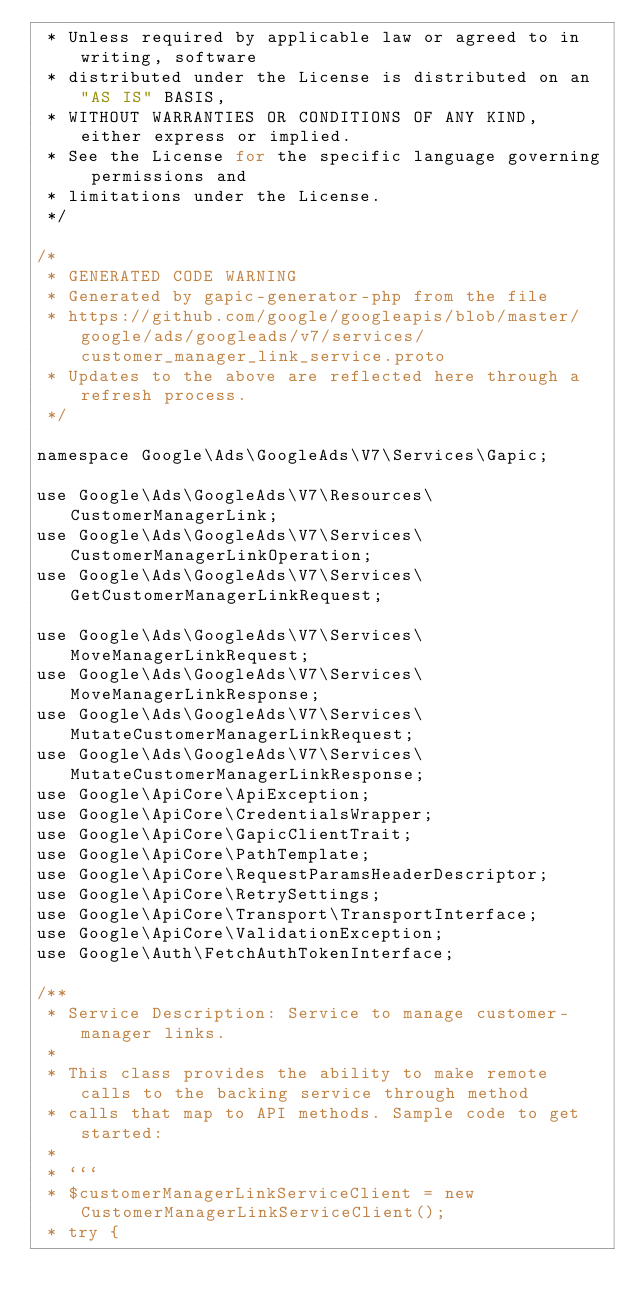Convert code to text. <code><loc_0><loc_0><loc_500><loc_500><_PHP_> * Unless required by applicable law or agreed to in writing, software
 * distributed under the License is distributed on an "AS IS" BASIS,
 * WITHOUT WARRANTIES OR CONDITIONS OF ANY KIND, either express or implied.
 * See the License for the specific language governing permissions and
 * limitations under the License.
 */

/*
 * GENERATED CODE WARNING
 * Generated by gapic-generator-php from the file
 * https://github.com/google/googleapis/blob/master/google/ads/googleads/v7/services/customer_manager_link_service.proto
 * Updates to the above are reflected here through a refresh process.
 */

namespace Google\Ads\GoogleAds\V7\Services\Gapic;

use Google\Ads\GoogleAds\V7\Resources\CustomerManagerLink;
use Google\Ads\GoogleAds\V7\Services\CustomerManagerLinkOperation;
use Google\Ads\GoogleAds\V7\Services\GetCustomerManagerLinkRequest;

use Google\Ads\GoogleAds\V7\Services\MoveManagerLinkRequest;
use Google\Ads\GoogleAds\V7\Services\MoveManagerLinkResponse;
use Google\Ads\GoogleAds\V7\Services\MutateCustomerManagerLinkRequest;
use Google\Ads\GoogleAds\V7\Services\MutateCustomerManagerLinkResponse;
use Google\ApiCore\ApiException;
use Google\ApiCore\CredentialsWrapper;
use Google\ApiCore\GapicClientTrait;
use Google\ApiCore\PathTemplate;
use Google\ApiCore\RequestParamsHeaderDescriptor;
use Google\ApiCore\RetrySettings;
use Google\ApiCore\Transport\TransportInterface;
use Google\ApiCore\ValidationException;
use Google\Auth\FetchAuthTokenInterface;

/**
 * Service Description: Service to manage customer-manager links.
 *
 * This class provides the ability to make remote calls to the backing service through method
 * calls that map to API methods. Sample code to get started:
 *
 * ```
 * $customerManagerLinkServiceClient = new CustomerManagerLinkServiceClient();
 * try {</code> 